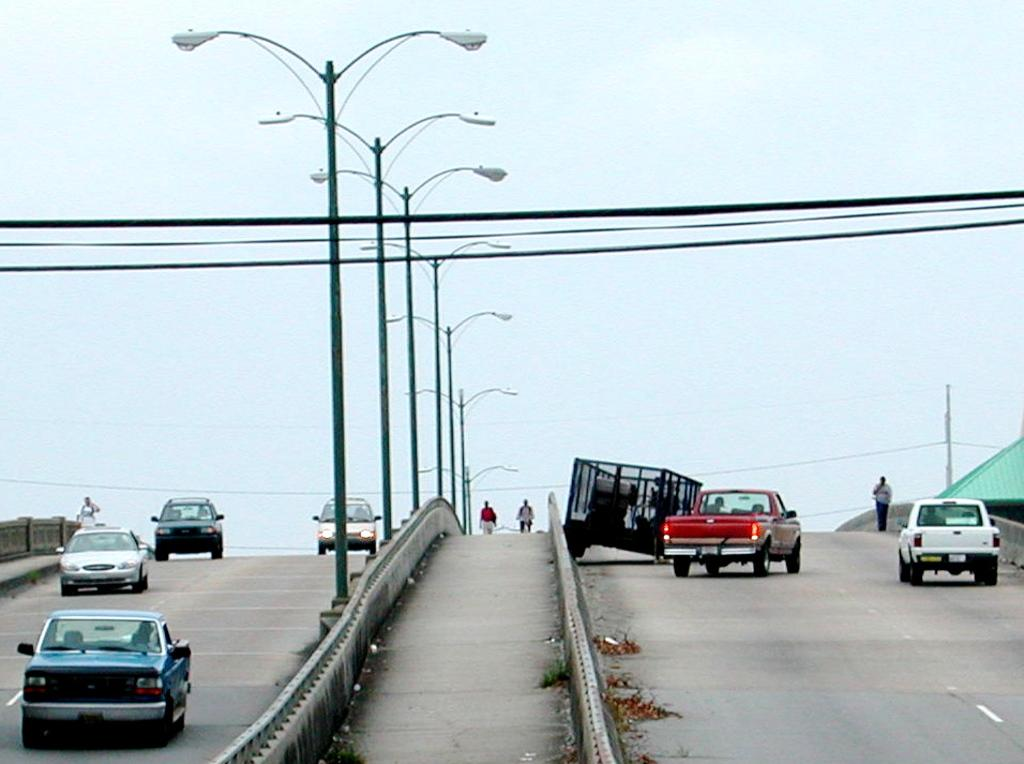What type of infrastructure is present in the image? There are roads in the image. What is happening on the roads? There are vehicles on the roads. Are there any people present in the image? Yes, there are people standing near the roads. What else can be seen in the image besides roads and people? There are wires, poles, street lights, and grass visible in the image. What is the profit margin of the science project being conducted by the babies in the image? There are no babies or science projects present in the image; it features roads, vehicles, people, wires, poles, street lights, and grass. 